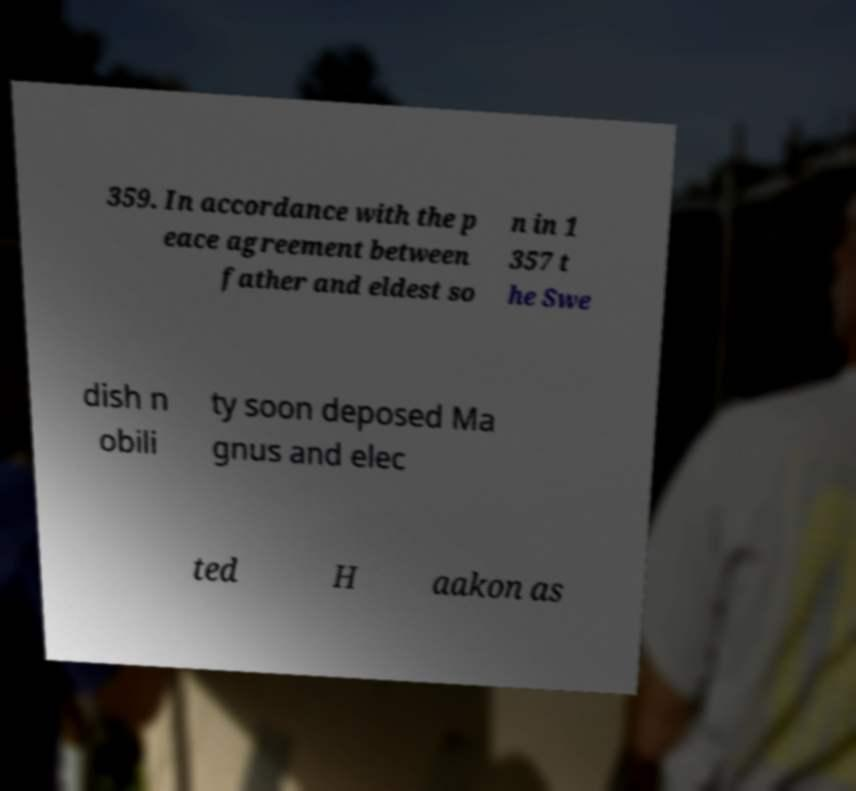Please read and relay the text visible in this image. What does it say? 359. In accordance with the p eace agreement between father and eldest so n in 1 357 t he Swe dish n obili ty soon deposed Ma gnus and elec ted H aakon as 